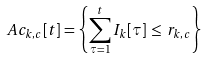Convert formula to latex. <formula><loc_0><loc_0><loc_500><loc_500>\ A c _ { k , c } [ t ] = \left \{ \sum _ { \tau = 1 } ^ { t } I _ { k } [ \tau ] \, \leq \, r _ { k , c } \right \}</formula> 